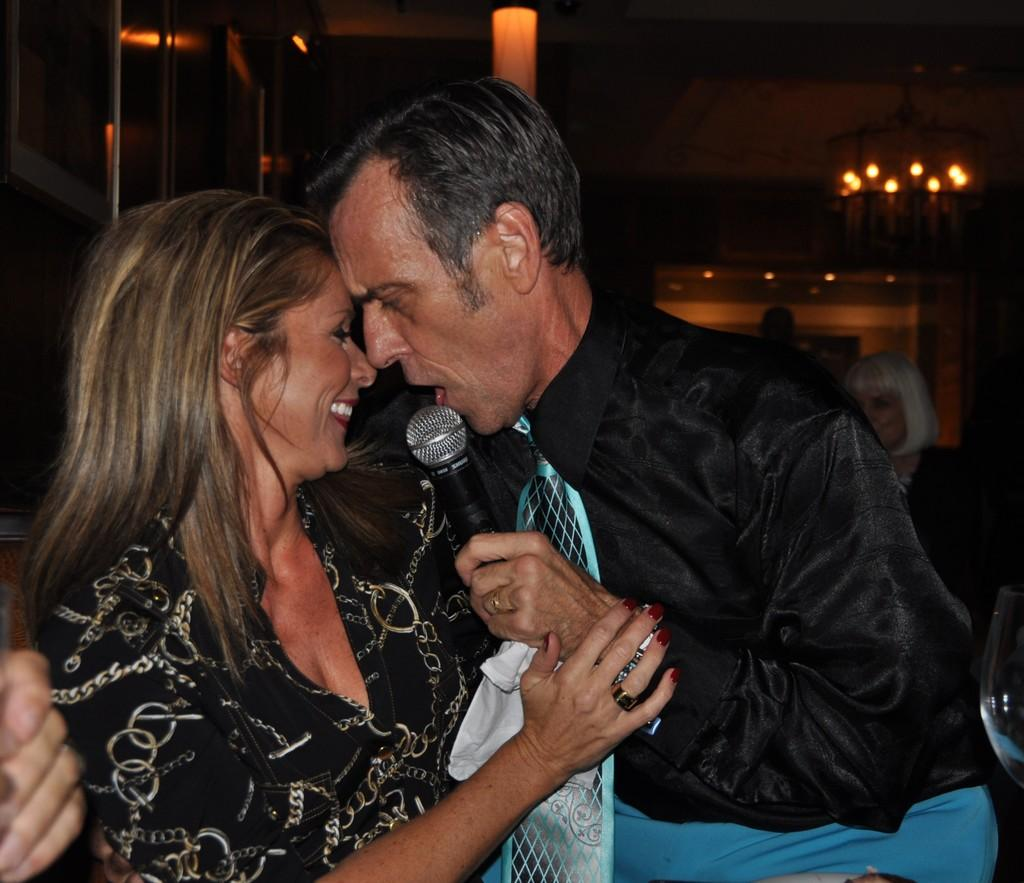Who are the people in the image? There is a woman and a man in the image. What is the man holding in the image? The man is holding a mic in the image. What object can be seen on a surface in the image? There is a glass in the image. Can you describe the background of the image? There is a woman and lights visible in the background of the image. What type of balloon can be seen floating in the background of the image? There is no balloon present in the image; only a woman and lights are visible in the background. What season is depicted in the image, considering the absence of snow or winter clothing? The image does not depict a specific season, as there is no indication of snow or winter clothing. 